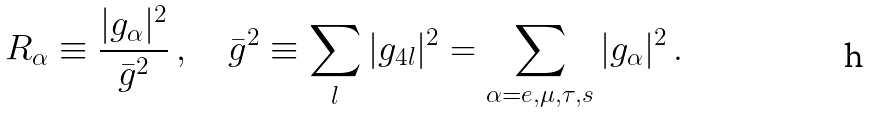<formula> <loc_0><loc_0><loc_500><loc_500>R _ { \alpha } \equiv \frac { | g _ { \alpha } | ^ { 2 } } { \bar { g } ^ { 2 } } \, , \quad \bar { g } ^ { 2 } \equiv \sum _ { l } | g _ { 4 l } | ^ { 2 } = \sum _ { \alpha = e , \mu , \tau , s } | g _ { \alpha } | ^ { 2 } \, .</formula> 